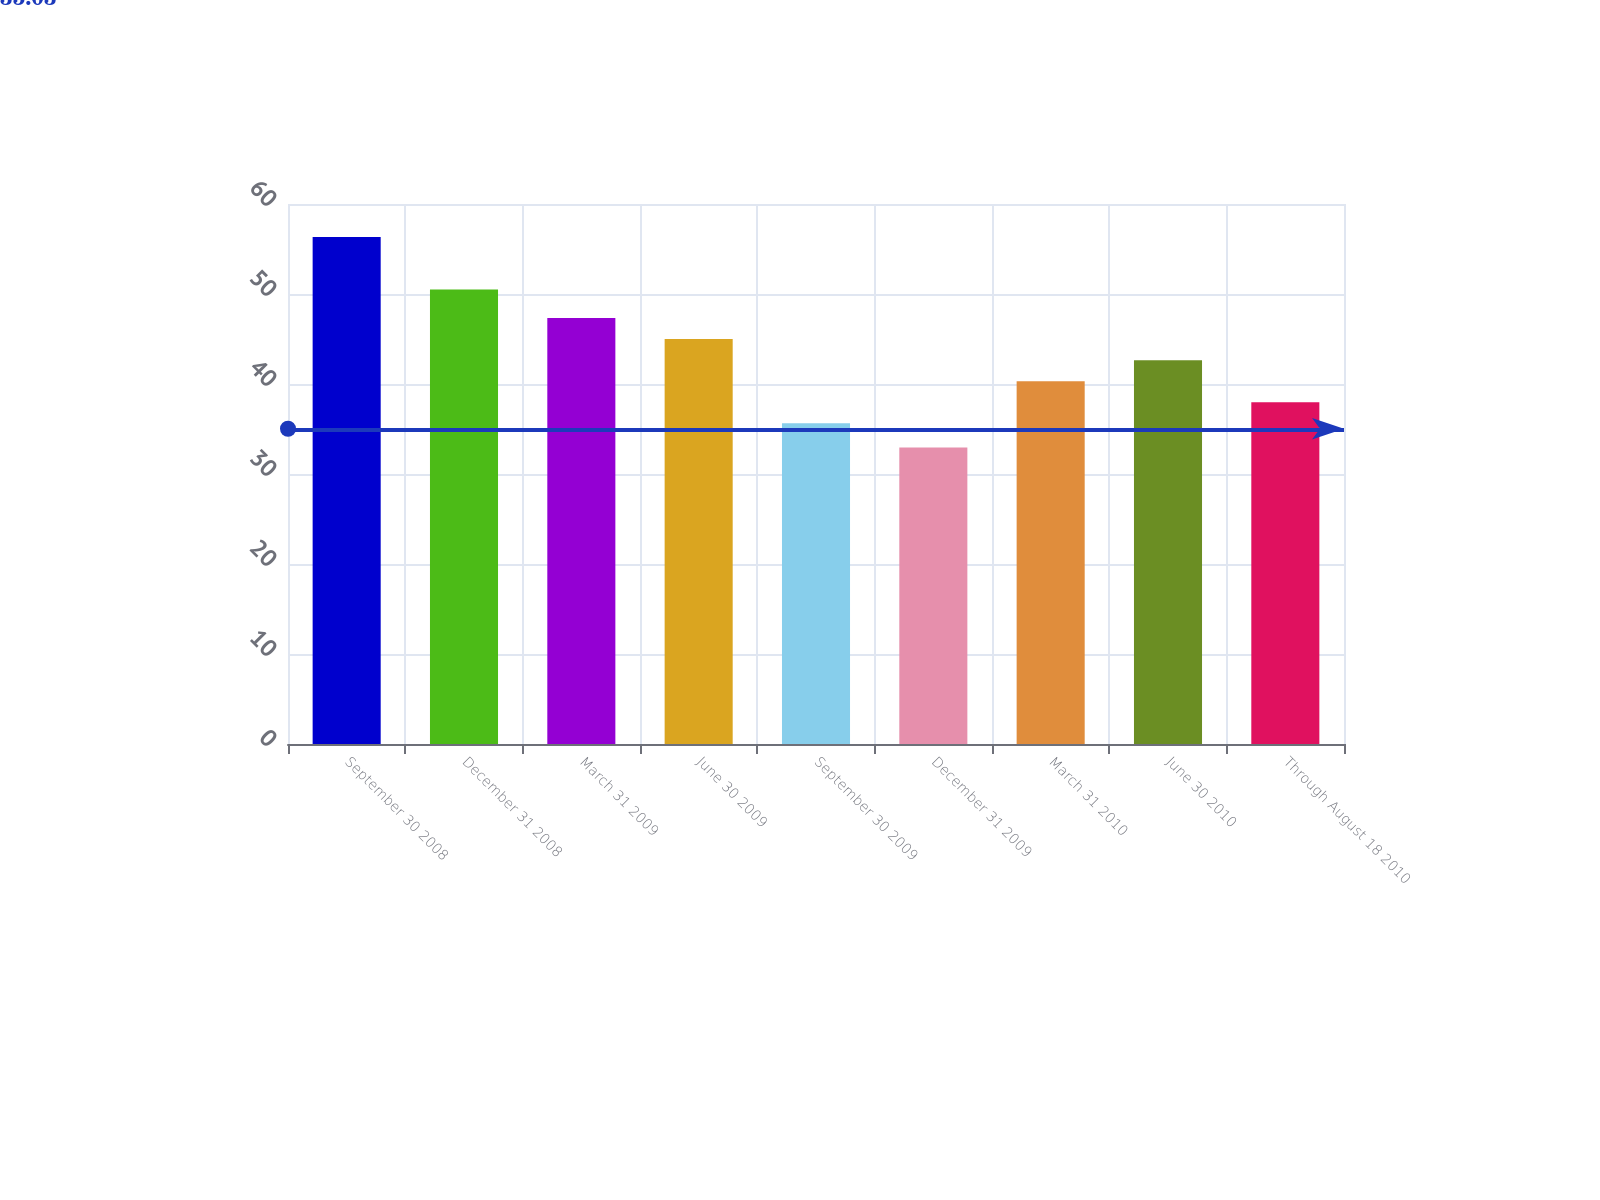Convert chart. <chart><loc_0><loc_0><loc_500><loc_500><bar_chart><fcel>September 30 2008<fcel>December 31 2008<fcel>March 31 2009<fcel>June 30 2009<fcel>September 30 2009<fcel>December 31 2009<fcel>March 31 2010<fcel>June 30 2010<fcel>Through August 18 2010<nl><fcel>56.34<fcel>50.5<fcel>47.33<fcel>44.99<fcel>35.63<fcel>32.95<fcel>40.31<fcel>42.65<fcel>37.97<nl></chart> 